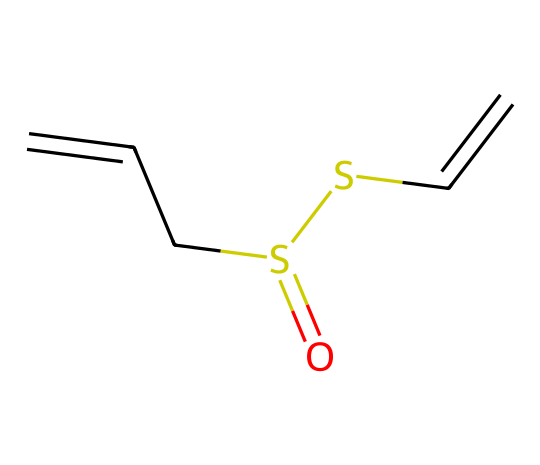what is the molecular formula of allicin? To determine the molecular formula, count the atoms in the structure using the SMILES representation. The formula can be derived as follows: there are 6 carbons (C), 10 hydrogens (H), 2 sulfurs (S), and 1 oxygen (O). Therefore, the molecular formula is C6H10O1S2.
Answer: C6H10OS2 how many carbons are in allicin? Counting the carbon atoms from the SMILES representation, there are 6 carbon atoms in the structure of allicin.
Answer: 6 how many double bonds are present in allicin? The presence of double bonds can be identified by looking for "=" symbols in the SMILES notation. There are two double bonds in allicin, indicated by the two "=" signs between the carbon and sulfur atoms.
Answer: 2 what functional groups are present in allicin? Looking at the structure, allicin contains thioether and sulfoxide functional groups, which can be identified through the presence of sulfur atoms linked to carbons and the presence of the sulfur-oxygen bond.
Answer: thioether and sulfoxide which element is responsible for the potential cybersecurity applications of allicin? Allicin contains sulfur, which is known for its unique electronic properties that may contribute to cybersecurity applications through the formation of connections in molecular electronics.
Answer: sulfur how does the structural arrangement of allicin influence its biological activity? The structural arrangement in allicin, particularly the positioning of the double bonds and sulfur atoms, contributes to its ability to interact with biological systems, enhancing its antimicrobial properties. The arrangement leads to increased reactivity with biological targets.
Answer: reactivity what is the significance of the sulfur atoms in allicin? The sulfur atoms in allicin play a critical role in its biological activity, as they can participate in redox reactions and contribute to the compound's ability to affect cellular processes, such as signal transduction.
Answer: redox reactions 